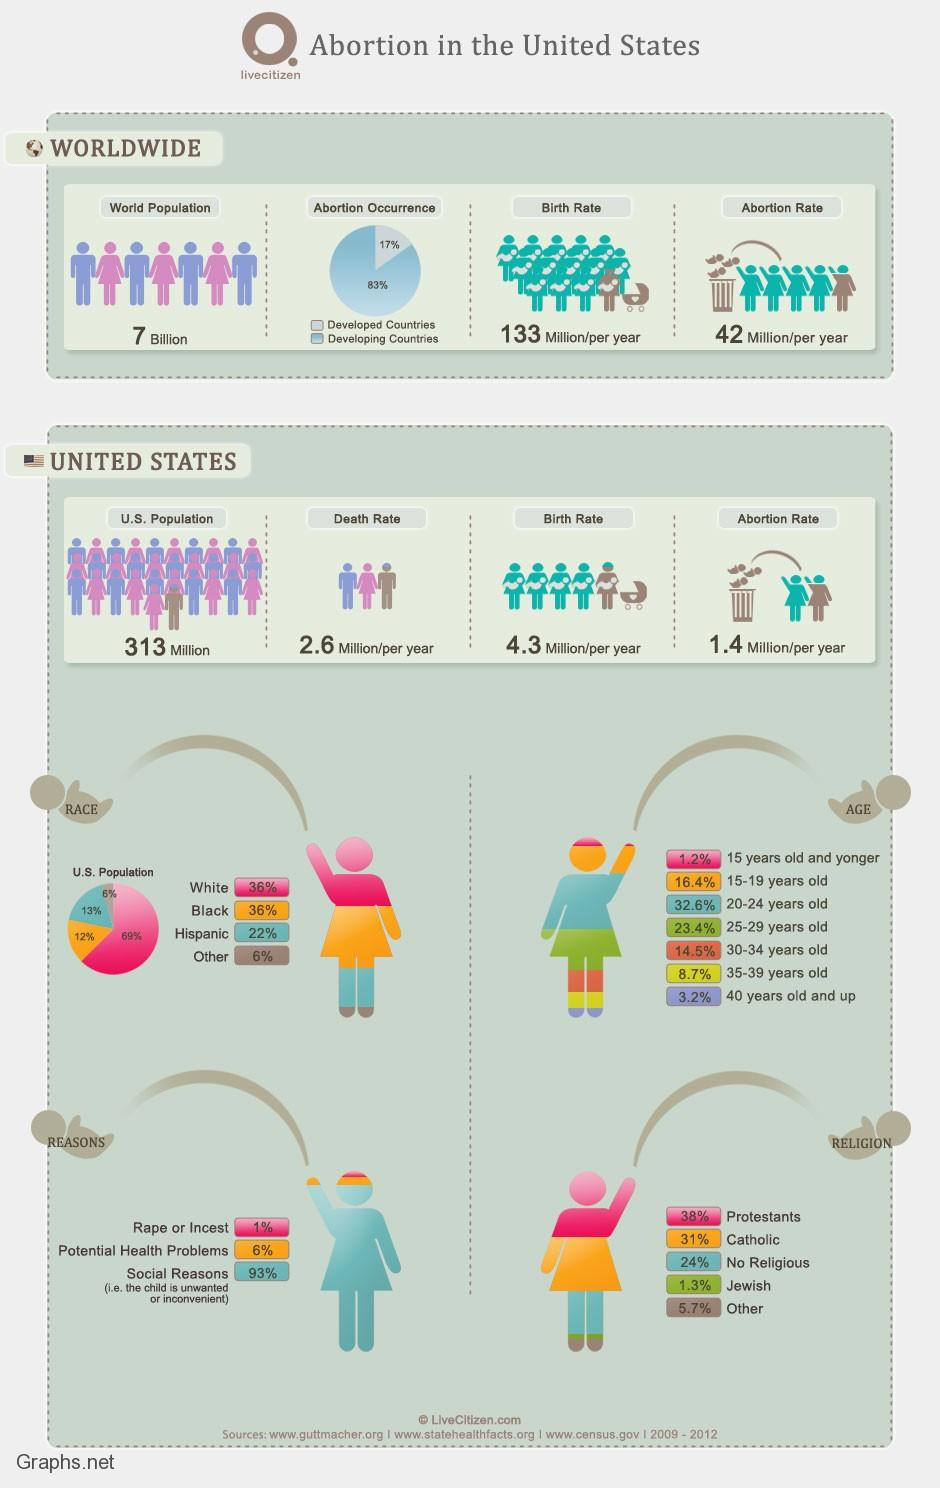Give some essential details in this illustration. The abortion percentage for Catholics and Jews is 32.3%. Developed countries have a lower percentage of abortions compared to developing countries. The death rate in the United States is currently 1.7 per year. Potential health problems are the second most common reason for abortions. The abortion rate for individuals under the age of 20 is 17.6%. 